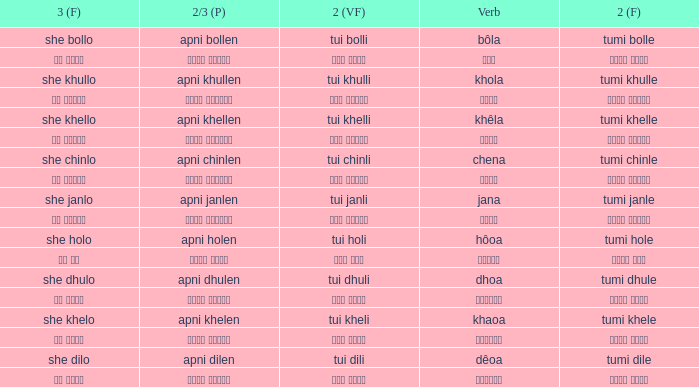What is the 2nd verb for Khola? Tumi khulle. 